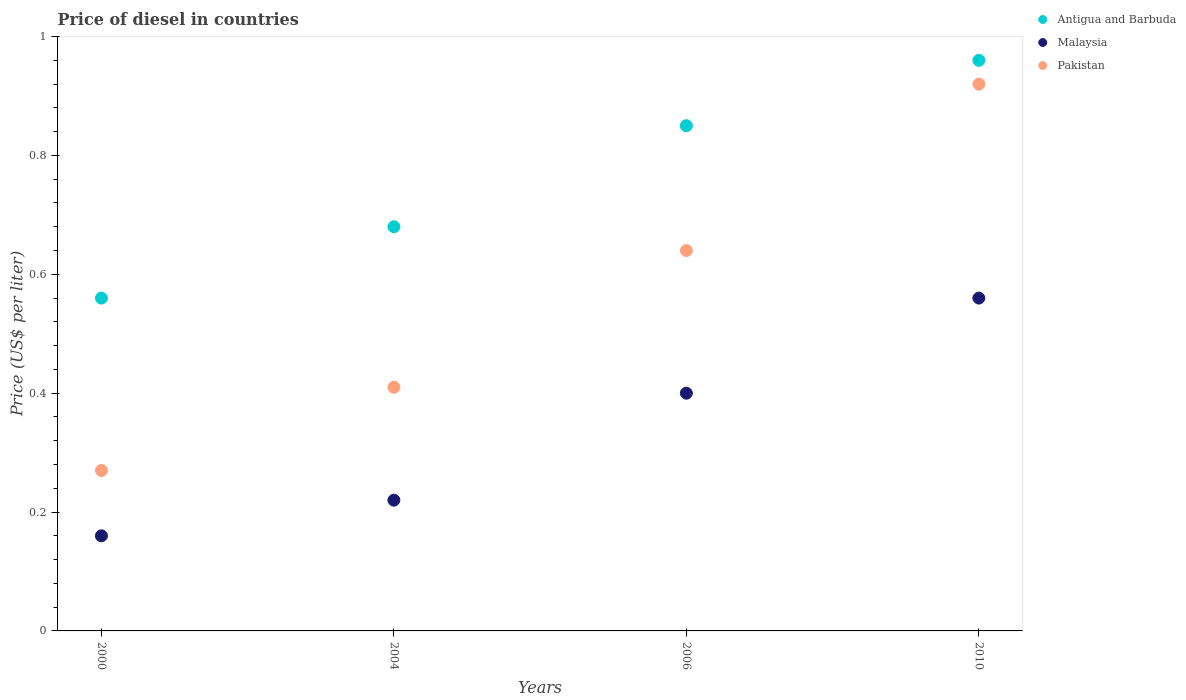How many different coloured dotlines are there?
Give a very brief answer. 3. What is the price of diesel in Malaysia in 2000?
Provide a short and direct response. 0.16. Across all years, what is the maximum price of diesel in Pakistan?
Keep it short and to the point. 0.92. Across all years, what is the minimum price of diesel in Antigua and Barbuda?
Your response must be concise. 0.56. In which year was the price of diesel in Pakistan minimum?
Ensure brevity in your answer.  2000. What is the total price of diesel in Antigua and Barbuda in the graph?
Give a very brief answer. 3.05. What is the difference between the price of diesel in Malaysia in 2006 and that in 2010?
Give a very brief answer. -0.16. What is the difference between the price of diesel in Antigua and Barbuda in 2004 and the price of diesel in Pakistan in 2000?
Provide a short and direct response. 0.41. What is the average price of diesel in Pakistan per year?
Your response must be concise. 0.56. In the year 2004, what is the difference between the price of diesel in Antigua and Barbuda and price of diesel in Malaysia?
Offer a very short reply. 0.46. What is the ratio of the price of diesel in Malaysia in 2000 to that in 2004?
Offer a terse response. 0.73. Is the price of diesel in Antigua and Barbuda in 2000 less than that in 2010?
Your answer should be compact. Yes. What is the difference between the highest and the second highest price of diesel in Pakistan?
Your response must be concise. 0.28. What is the difference between the highest and the lowest price of diesel in Pakistan?
Your response must be concise. 0.65. In how many years, is the price of diesel in Antigua and Barbuda greater than the average price of diesel in Antigua and Barbuda taken over all years?
Make the answer very short. 2. Is it the case that in every year, the sum of the price of diesel in Antigua and Barbuda and price of diesel in Malaysia  is greater than the price of diesel in Pakistan?
Make the answer very short. Yes. Does the price of diesel in Pakistan monotonically increase over the years?
Provide a succinct answer. Yes. Is the price of diesel in Pakistan strictly greater than the price of diesel in Antigua and Barbuda over the years?
Keep it short and to the point. No. How many dotlines are there?
Make the answer very short. 3. Where does the legend appear in the graph?
Give a very brief answer. Top right. How many legend labels are there?
Your answer should be compact. 3. What is the title of the graph?
Offer a very short reply. Price of diesel in countries. Does "Palau" appear as one of the legend labels in the graph?
Your answer should be very brief. No. What is the label or title of the X-axis?
Your answer should be very brief. Years. What is the label or title of the Y-axis?
Your answer should be very brief. Price (US$ per liter). What is the Price (US$ per liter) in Antigua and Barbuda in 2000?
Offer a terse response. 0.56. What is the Price (US$ per liter) in Malaysia in 2000?
Ensure brevity in your answer.  0.16. What is the Price (US$ per liter) in Pakistan in 2000?
Give a very brief answer. 0.27. What is the Price (US$ per liter) of Antigua and Barbuda in 2004?
Provide a short and direct response. 0.68. What is the Price (US$ per liter) of Malaysia in 2004?
Give a very brief answer. 0.22. What is the Price (US$ per liter) of Pakistan in 2004?
Your answer should be very brief. 0.41. What is the Price (US$ per liter) of Malaysia in 2006?
Your response must be concise. 0.4. What is the Price (US$ per liter) of Pakistan in 2006?
Provide a short and direct response. 0.64. What is the Price (US$ per liter) in Malaysia in 2010?
Your answer should be very brief. 0.56. Across all years, what is the maximum Price (US$ per liter) of Malaysia?
Keep it short and to the point. 0.56. Across all years, what is the minimum Price (US$ per liter) of Antigua and Barbuda?
Ensure brevity in your answer.  0.56. Across all years, what is the minimum Price (US$ per liter) of Malaysia?
Offer a very short reply. 0.16. Across all years, what is the minimum Price (US$ per liter) of Pakistan?
Your answer should be very brief. 0.27. What is the total Price (US$ per liter) of Antigua and Barbuda in the graph?
Offer a very short reply. 3.05. What is the total Price (US$ per liter) of Malaysia in the graph?
Make the answer very short. 1.34. What is the total Price (US$ per liter) of Pakistan in the graph?
Make the answer very short. 2.24. What is the difference between the Price (US$ per liter) of Antigua and Barbuda in 2000 and that in 2004?
Provide a short and direct response. -0.12. What is the difference between the Price (US$ per liter) of Malaysia in 2000 and that in 2004?
Provide a succinct answer. -0.06. What is the difference between the Price (US$ per liter) of Pakistan in 2000 and that in 2004?
Offer a very short reply. -0.14. What is the difference between the Price (US$ per liter) of Antigua and Barbuda in 2000 and that in 2006?
Your answer should be compact. -0.29. What is the difference between the Price (US$ per liter) of Malaysia in 2000 and that in 2006?
Keep it short and to the point. -0.24. What is the difference between the Price (US$ per liter) in Pakistan in 2000 and that in 2006?
Offer a very short reply. -0.37. What is the difference between the Price (US$ per liter) in Malaysia in 2000 and that in 2010?
Offer a very short reply. -0.4. What is the difference between the Price (US$ per liter) in Pakistan in 2000 and that in 2010?
Provide a short and direct response. -0.65. What is the difference between the Price (US$ per liter) in Antigua and Barbuda in 2004 and that in 2006?
Provide a short and direct response. -0.17. What is the difference between the Price (US$ per liter) in Malaysia in 2004 and that in 2006?
Provide a succinct answer. -0.18. What is the difference between the Price (US$ per liter) in Pakistan in 2004 and that in 2006?
Provide a succinct answer. -0.23. What is the difference between the Price (US$ per liter) in Antigua and Barbuda in 2004 and that in 2010?
Make the answer very short. -0.28. What is the difference between the Price (US$ per liter) in Malaysia in 2004 and that in 2010?
Your answer should be very brief. -0.34. What is the difference between the Price (US$ per liter) in Pakistan in 2004 and that in 2010?
Provide a succinct answer. -0.51. What is the difference between the Price (US$ per liter) in Antigua and Barbuda in 2006 and that in 2010?
Offer a very short reply. -0.11. What is the difference between the Price (US$ per liter) in Malaysia in 2006 and that in 2010?
Offer a terse response. -0.16. What is the difference between the Price (US$ per liter) in Pakistan in 2006 and that in 2010?
Ensure brevity in your answer.  -0.28. What is the difference between the Price (US$ per liter) of Antigua and Barbuda in 2000 and the Price (US$ per liter) of Malaysia in 2004?
Your answer should be very brief. 0.34. What is the difference between the Price (US$ per liter) in Malaysia in 2000 and the Price (US$ per liter) in Pakistan in 2004?
Your answer should be compact. -0.25. What is the difference between the Price (US$ per liter) in Antigua and Barbuda in 2000 and the Price (US$ per liter) in Malaysia in 2006?
Give a very brief answer. 0.16. What is the difference between the Price (US$ per liter) in Antigua and Barbuda in 2000 and the Price (US$ per liter) in Pakistan in 2006?
Keep it short and to the point. -0.08. What is the difference between the Price (US$ per liter) of Malaysia in 2000 and the Price (US$ per liter) of Pakistan in 2006?
Provide a short and direct response. -0.48. What is the difference between the Price (US$ per liter) of Antigua and Barbuda in 2000 and the Price (US$ per liter) of Malaysia in 2010?
Provide a short and direct response. 0. What is the difference between the Price (US$ per liter) of Antigua and Barbuda in 2000 and the Price (US$ per liter) of Pakistan in 2010?
Your response must be concise. -0.36. What is the difference between the Price (US$ per liter) in Malaysia in 2000 and the Price (US$ per liter) in Pakistan in 2010?
Provide a short and direct response. -0.76. What is the difference between the Price (US$ per liter) of Antigua and Barbuda in 2004 and the Price (US$ per liter) of Malaysia in 2006?
Keep it short and to the point. 0.28. What is the difference between the Price (US$ per liter) in Malaysia in 2004 and the Price (US$ per liter) in Pakistan in 2006?
Offer a very short reply. -0.42. What is the difference between the Price (US$ per liter) of Antigua and Barbuda in 2004 and the Price (US$ per liter) of Malaysia in 2010?
Make the answer very short. 0.12. What is the difference between the Price (US$ per liter) in Antigua and Barbuda in 2004 and the Price (US$ per liter) in Pakistan in 2010?
Give a very brief answer. -0.24. What is the difference between the Price (US$ per liter) of Malaysia in 2004 and the Price (US$ per liter) of Pakistan in 2010?
Make the answer very short. -0.7. What is the difference between the Price (US$ per liter) of Antigua and Barbuda in 2006 and the Price (US$ per liter) of Malaysia in 2010?
Offer a very short reply. 0.29. What is the difference between the Price (US$ per liter) of Antigua and Barbuda in 2006 and the Price (US$ per liter) of Pakistan in 2010?
Your response must be concise. -0.07. What is the difference between the Price (US$ per liter) of Malaysia in 2006 and the Price (US$ per liter) of Pakistan in 2010?
Make the answer very short. -0.52. What is the average Price (US$ per liter) of Antigua and Barbuda per year?
Offer a very short reply. 0.76. What is the average Price (US$ per liter) in Malaysia per year?
Offer a terse response. 0.34. What is the average Price (US$ per liter) of Pakistan per year?
Make the answer very short. 0.56. In the year 2000, what is the difference between the Price (US$ per liter) in Antigua and Barbuda and Price (US$ per liter) in Malaysia?
Give a very brief answer. 0.4. In the year 2000, what is the difference between the Price (US$ per liter) of Antigua and Barbuda and Price (US$ per liter) of Pakistan?
Provide a succinct answer. 0.29. In the year 2000, what is the difference between the Price (US$ per liter) of Malaysia and Price (US$ per liter) of Pakistan?
Provide a succinct answer. -0.11. In the year 2004, what is the difference between the Price (US$ per liter) of Antigua and Barbuda and Price (US$ per liter) of Malaysia?
Your answer should be very brief. 0.46. In the year 2004, what is the difference between the Price (US$ per liter) in Antigua and Barbuda and Price (US$ per liter) in Pakistan?
Ensure brevity in your answer.  0.27. In the year 2004, what is the difference between the Price (US$ per liter) of Malaysia and Price (US$ per liter) of Pakistan?
Offer a terse response. -0.19. In the year 2006, what is the difference between the Price (US$ per liter) of Antigua and Barbuda and Price (US$ per liter) of Malaysia?
Give a very brief answer. 0.45. In the year 2006, what is the difference between the Price (US$ per liter) of Antigua and Barbuda and Price (US$ per liter) of Pakistan?
Your response must be concise. 0.21. In the year 2006, what is the difference between the Price (US$ per liter) of Malaysia and Price (US$ per liter) of Pakistan?
Offer a terse response. -0.24. In the year 2010, what is the difference between the Price (US$ per liter) of Antigua and Barbuda and Price (US$ per liter) of Malaysia?
Provide a succinct answer. 0.4. In the year 2010, what is the difference between the Price (US$ per liter) in Malaysia and Price (US$ per liter) in Pakistan?
Keep it short and to the point. -0.36. What is the ratio of the Price (US$ per liter) of Antigua and Barbuda in 2000 to that in 2004?
Your response must be concise. 0.82. What is the ratio of the Price (US$ per liter) in Malaysia in 2000 to that in 2004?
Ensure brevity in your answer.  0.73. What is the ratio of the Price (US$ per liter) of Pakistan in 2000 to that in 2004?
Give a very brief answer. 0.66. What is the ratio of the Price (US$ per liter) in Antigua and Barbuda in 2000 to that in 2006?
Provide a short and direct response. 0.66. What is the ratio of the Price (US$ per liter) in Pakistan in 2000 to that in 2006?
Your answer should be very brief. 0.42. What is the ratio of the Price (US$ per liter) of Antigua and Barbuda in 2000 to that in 2010?
Provide a succinct answer. 0.58. What is the ratio of the Price (US$ per liter) of Malaysia in 2000 to that in 2010?
Keep it short and to the point. 0.29. What is the ratio of the Price (US$ per liter) of Pakistan in 2000 to that in 2010?
Your response must be concise. 0.29. What is the ratio of the Price (US$ per liter) in Antigua and Barbuda in 2004 to that in 2006?
Give a very brief answer. 0.8. What is the ratio of the Price (US$ per liter) in Malaysia in 2004 to that in 2006?
Provide a succinct answer. 0.55. What is the ratio of the Price (US$ per liter) in Pakistan in 2004 to that in 2006?
Your answer should be very brief. 0.64. What is the ratio of the Price (US$ per liter) in Antigua and Barbuda in 2004 to that in 2010?
Give a very brief answer. 0.71. What is the ratio of the Price (US$ per liter) of Malaysia in 2004 to that in 2010?
Your answer should be compact. 0.39. What is the ratio of the Price (US$ per liter) of Pakistan in 2004 to that in 2010?
Provide a succinct answer. 0.45. What is the ratio of the Price (US$ per liter) in Antigua and Barbuda in 2006 to that in 2010?
Ensure brevity in your answer.  0.89. What is the ratio of the Price (US$ per liter) of Malaysia in 2006 to that in 2010?
Keep it short and to the point. 0.71. What is the ratio of the Price (US$ per liter) of Pakistan in 2006 to that in 2010?
Keep it short and to the point. 0.7. What is the difference between the highest and the second highest Price (US$ per liter) in Antigua and Barbuda?
Your answer should be very brief. 0.11. What is the difference between the highest and the second highest Price (US$ per liter) in Malaysia?
Ensure brevity in your answer.  0.16. What is the difference between the highest and the second highest Price (US$ per liter) in Pakistan?
Your answer should be compact. 0.28. What is the difference between the highest and the lowest Price (US$ per liter) of Antigua and Barbuda?
Your answer should be very brief. 0.4. What is the difference between the highest and the lowest Price (US$ per liter) of Pakistan?
Your answer should be very brief. 0.65. 